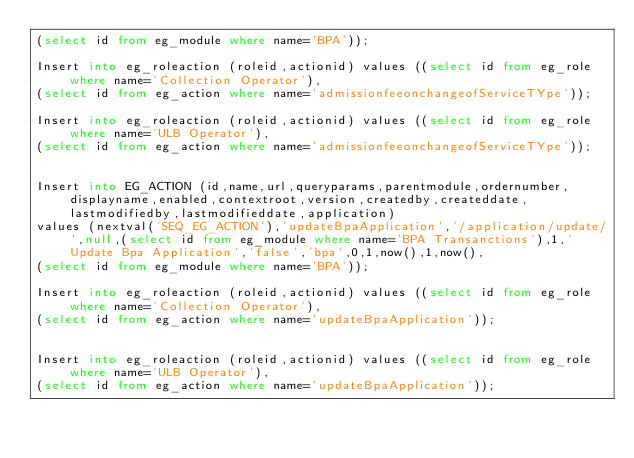Convert code to text. <code><loc_0><loc_0><loc_500><loc_500><_SQL_>(select id from eg_module where name='BPA'));

Insert into eg_roleaction (roleid,actionid) values ((select id from eg_role where name='Collection Operator'),
(select id from eg_action where name='admissionfeeonchangeofServiceTYpe'));

Insert into eg_roleaction (roleid,actionid) values ((select id from eg_role where name='ULB Operator'),
(select id from eg_action where name='admissionfeeonchangeofServiceTYpe'));


Insert into EG_ACTION (id,name,url,queryparams,parentmodule,ordernumber,displayname,enabled,contextroot,version,createdby,createddate,lastmodifiedby,lastmodifieddate,application) 
values (nextval('SEQ_EG_ACTION'),'updateBpaApplication','/application/update/',null,(select id from eg_module where name='BPA Transanctions'),1,'Update Bpa Application','false','bpa',0,1,now(),1,now(),
(select id from eg_module where name='BPA'));

Insert into eg_roleaction (roleid,actionid) values ((select id from eg_role where name='Collection Operator'),
(select id from eg_action where name='updateBpaApplication'));


Insert into eg_roleaction (roleid,actionid) values ((select id from eg_role where name='ULB Operator'),
(select id from eg_action where name='updateBpaApplication'));</code> 